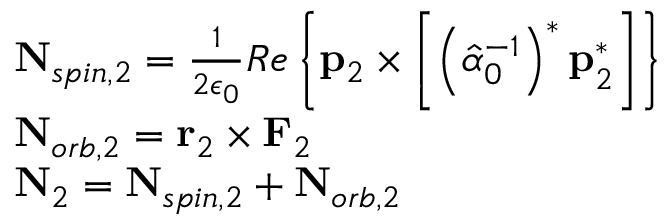Convert formula to latex. <formula><loc_0><loc_0><loc_500><loc_500>\begin{array} { r l } & { N _ { s p i n , 2 } = \frac { 1 } { 2 \epsilon _ { 0 } } R e \left \{ p _ { 2 } \times \left [ \left ( \hat { \alpha } _ { 0 } ^ { - 1 } \right ) ^ { * } p _ { 2 } ^ { * } \right ] \right \} } \\ & { N _ { o r b , 2 } = r _ { 2 } \times F _ { 2 } } \\ & { N _ { 2 } = N _ { s p i n , 2 } + N _ { o r b , 2 } } \end{array}</formula> 